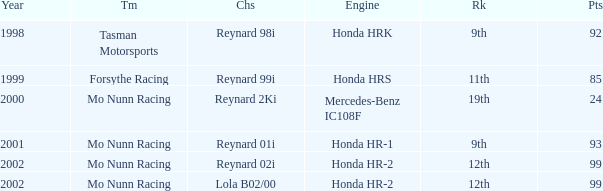What is the rank of the reynard 2ki chassis before 2002? 19th. 